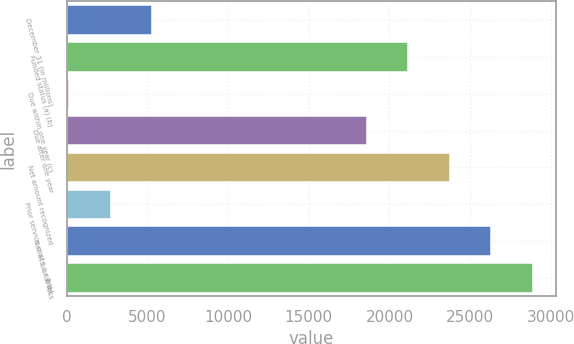Convert chart. <chart><loc_0><loc_0><loc_500><loc_500><bar_chart><fcel>December 31 (In millions)<fcel>Funded status (a) (b)<fcel>Due within one year (c)<fcel>Due after one year<fcel>Net amount recognized<fcel>Prior service cost ( c r e d i<fcel>Net actuarial loss<fcel>Total<nl><fcel>5295.8<fcel>21173.4<fcel>159<fcel>18605<fcel>23741.8<fcel>2727.4<fcel>26310.2<fcel>28878.6<nl></chart> 